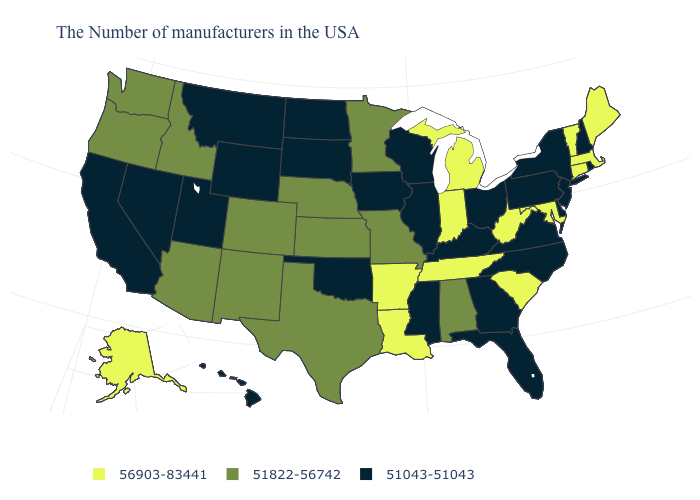What is the value of Virginia?
Quick response, please. 51043-51043. What is the lowest value in the USA?
Be succinct. 51043-51043. Name the states that have a value in the range 51043-51043?
Be succinct. Rhode Island, New Hampshire, New York, New Jersey, Delaware, Pennsylvania, Virginia, North Carolina, Ohio, Florida, Georgia, Kentucky, Wisconsin, Illinois, Mississippi, Iowa, Oklahoma, South Dakota, North Dakota, Wyoming, Utah, Montana, Nevada, California, Hawaii. Which states hav the highest value in the Northeast?
Give a very brief answer. Maine, Massachusetts, Vermont, Connecticut. Name the states that have a value in the range 51043-51043?
Concise answer only. Rhode Island, New Hampshire, New York, New Jersey, Delaware, Pennsylvania, Virginia, North Carolina, Ohio, Florida, Georgia, Kentucky, Wisconsin, Illinois, Mississippi, Iowa, Oklahoma, South Dakota, North Dakota, Wyoming, Utah, Montana, Nevada, California, Hawaii. Name the states that have a value in the range 56903-83441?
Give a very brief answer. Maine, Massachusetts, Vermont, Connecticut, Maryland, South Carolina, West Virginia, Michigan, Indiana, Tennessee, Louisiana, Arkansas, Alaska. What is the value of Montana?
Write a very short answer. 51043-51043. Does Missouri have the same value as New Jersey?
Concise answer only. No. Does Wisconsin have the lowest value in the USA?
Keep it brief. Yes. Which states have the lowest value in the South?
Concise answer only. Delaware, Virginia, North Carolina, Florida, Georgia, Kentucky, Mississippi, Oklahoma. Name the states that have a value in the range 51043-51043?
Short answer required. Rhode Island, New Hampshire, New York, New Jersey, Delaware, Pennsylvania, Virginia, North Carolina, Ohio, Florida, Georgia, Kentucky, Wisconsin, Illinois, Mississippi, Iowa, Oklahoma, South Dakota, North Dakota, Wyoming, Utah, Montana, Nevada, California, Hawaii. Among the states that border Indiana , which have the lowest value?
Keep it brief. Ohio, Kentucky, Illinois. Does Washington have the lowest value in the West?
Short answer required. No. What is the lowest value in states that border Louisiana?
Answer briefly. 51043-51043. 